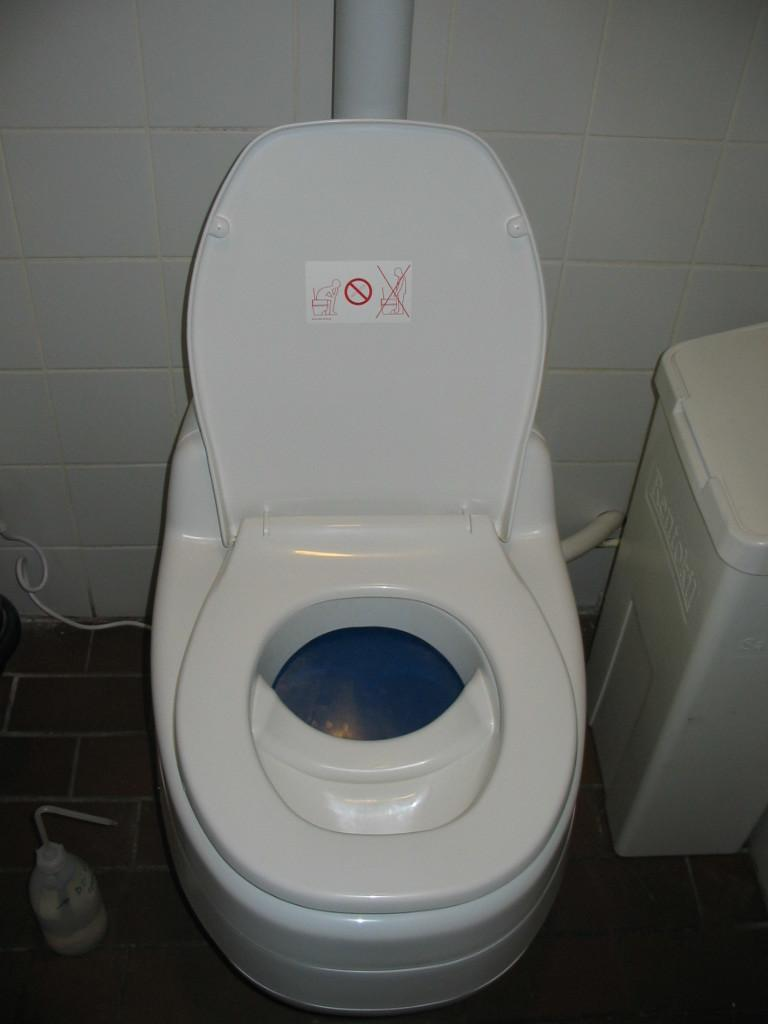What type of flooring is visible in the image? There is a tile floor in the image. What is the wall made of in the image? There is a tile wall in the image. What type of furniture is present in the image? There is a toilet cupboard in the image. What is attached to the wall in the image? There is a sign-sticker in the image. What plumbing fixture is visible in the image? There is a pipe in the image. What type of container is present in the image? There is a bin in the image. What type of object is present in the image that might contain liquid? There is a bottle in the image. Can you describe any other objects present in the image? There are other objects in the image, but their specific details are not mentioned in the provided facts. What type of fruit is hanging from the pipe in the image? There is no fruit present in the image, and the pipe is not associated with any fruit. 